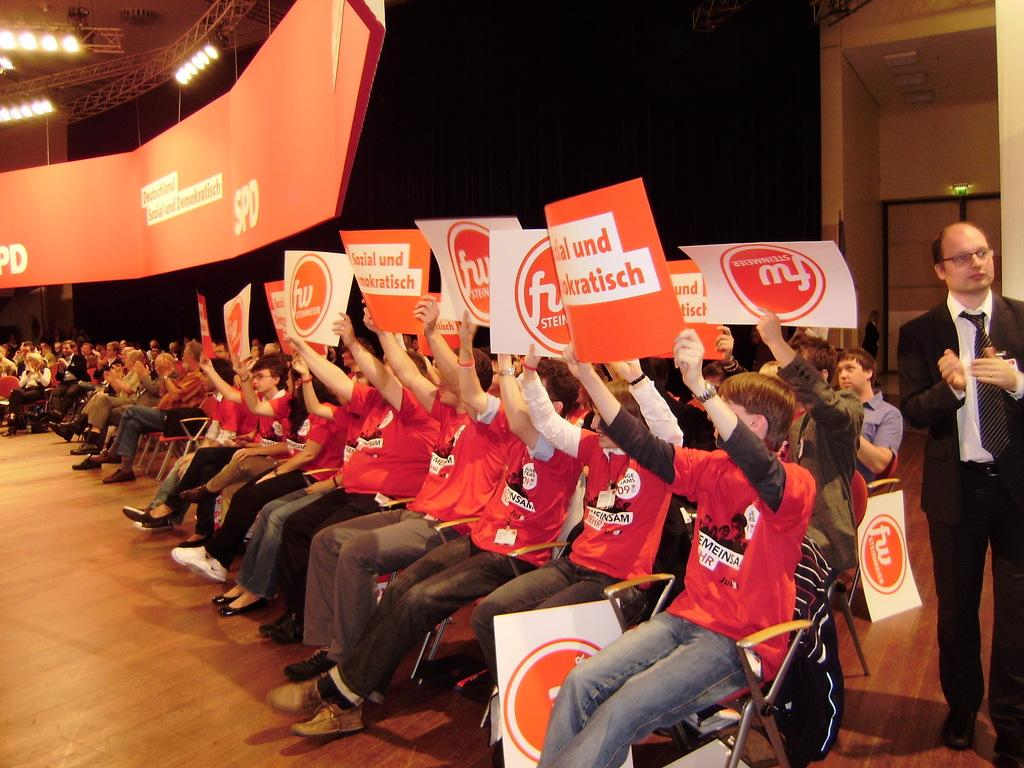How many people are in the image? There are persons in the image, but the exact number is not specified. What are the persons doing in the image? The persons are sitting on chairs and holding cards. What can be seen at the top of the image? There are lights at the top of the image. What type of scent is emitted by the cards in the image? There is no mention of a scent in the image, and cards typically do not emit any scent. 